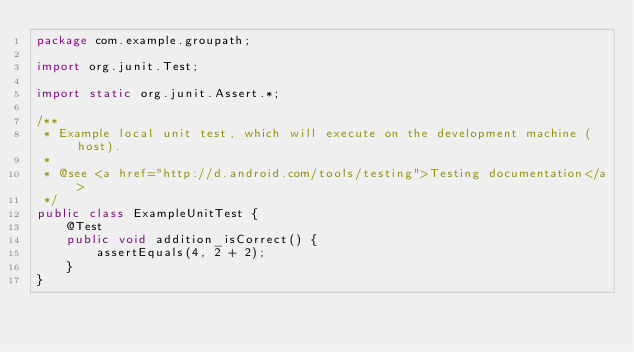<code> <loc_0><loc_0><loc_500><loc_500><_Java_>package com.example.groupath;

import org.junit.Test;

import static org.junit.Assert.*;

/**
 * Example local unit test, which will execute on the development machine (host).
 *
 * @see <a href="http://d.android.com/tools/testing">Testing documentation</a>
 */
public class ExampleUnitTest {
    @Test
    public void addition_isCorrect() {
        assertEquals(4, 2 + 2);
    }
}</code> 